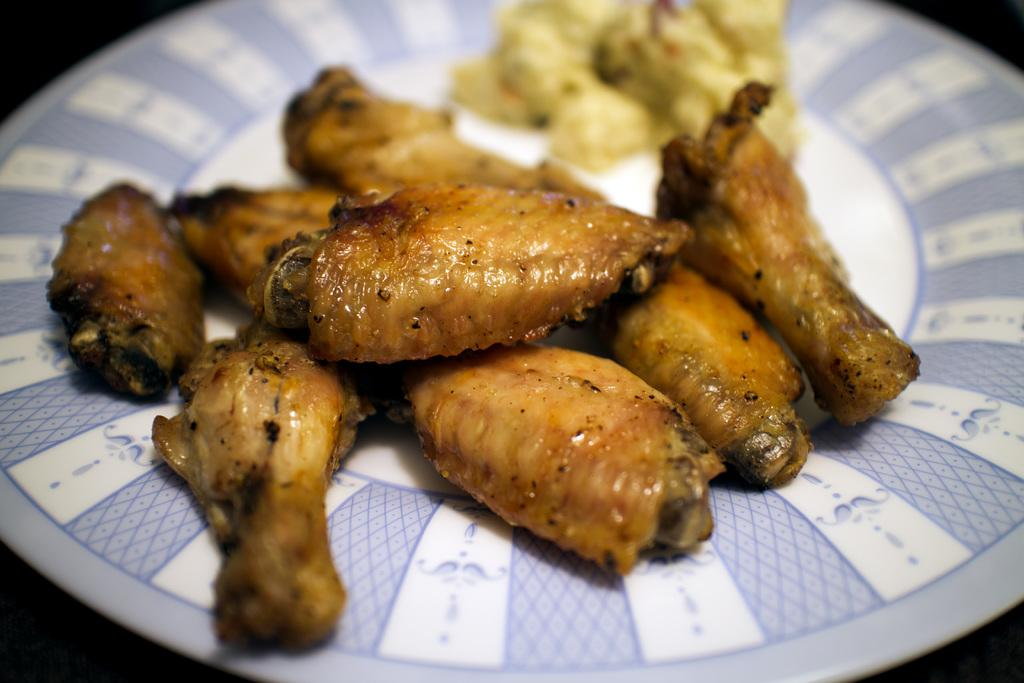What is present on the plate in the image? There is food on the plate in the image. What type of food can be seen on the plate? The food contains meat. What type of quiver is visible in the image? There is no quiver present in the image. Is the meat on the plate attached to a spring? There is no spring present in the image, and the meat is not attached to one. 